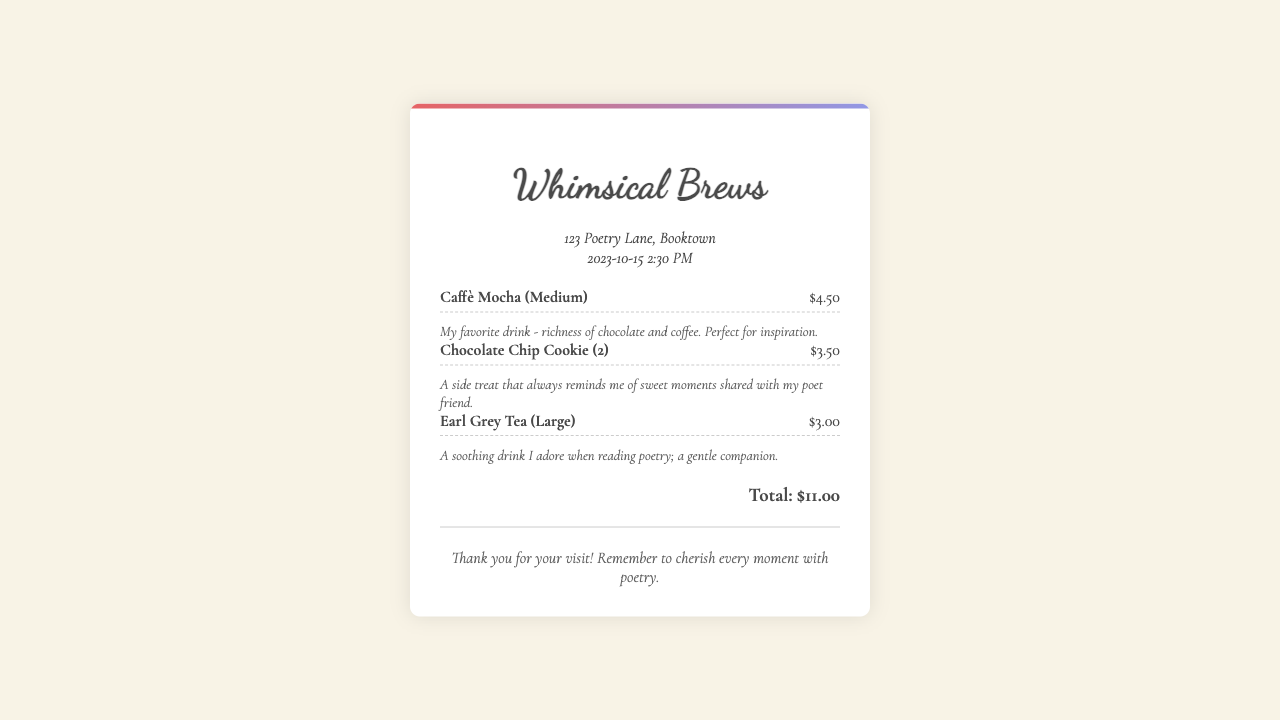what is the name of the coffee shop? The coffee shop is called "Whimsical Brews," as indicated at the top of the receipt.
Answer: Whimsical Brews what date and time is the receipt dated? The receipt shows the date and time as "2023-10-15 2:30 PM."
Answer: 2023-10-15 2:30 PM how much did the Caffè Mocha cost? The receipt lists the cost of the Caffè Mocha as $4.50.
Answer: $4.50 what is the total amount spent? The receipt specifies the total amount spent as $11.00.
Answer: $11.00 how many chocolate chip cookies are listed? The receipt shows that 2 chocolate chip cookies were purchased.
Answer: 2 what drink is mentioned as a favorite? The receipt notes that the Caffè Mocha is the favorite drink.
Answer: Caffè Mocha what item on the receipt comes with a note about sweet moments? The note about sweet moments is associated with the chocolate chip cookies.
Answer: Chocolate Chip Cookie what is the soothing drink enjoyed while reading poetry? The Earl Grey Tea is described as a soothing drink for reading poetry.
Answer: Earl Grey Tea what message is conveyed at the bottom of the receipt? The message reminds the visitor to cherish every moment with poetry.
Answer: cherish every moment with poetry 